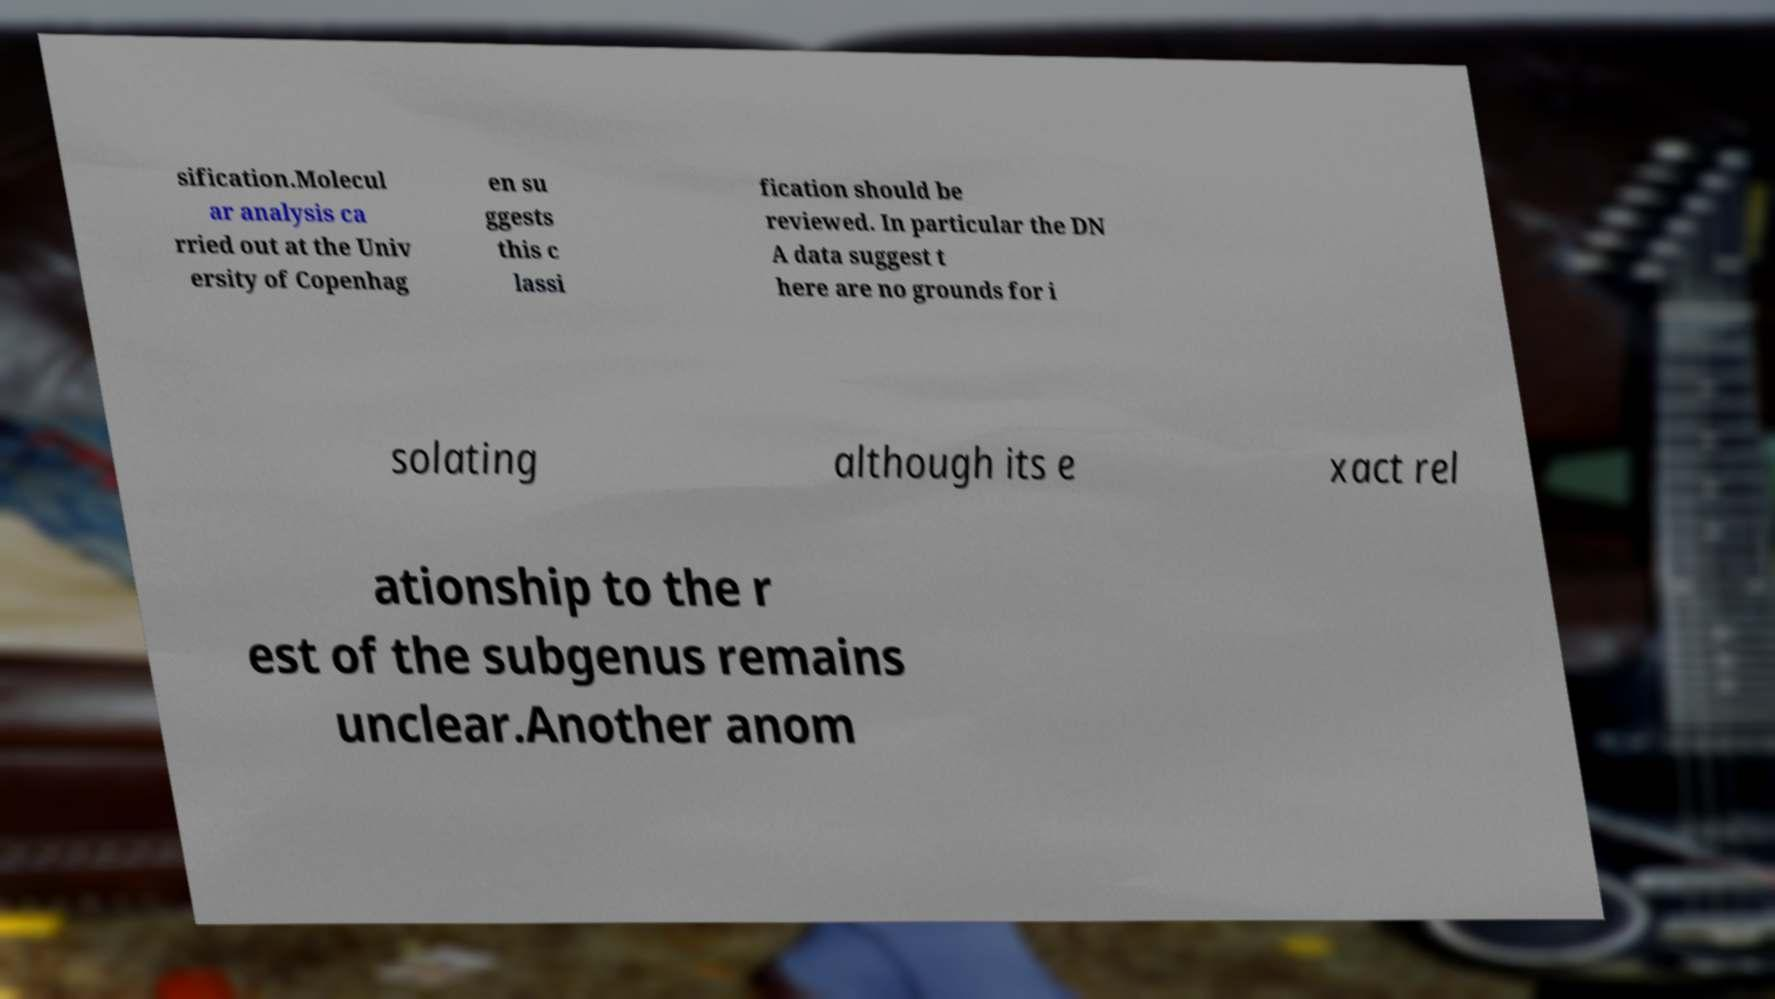Can you read and provide the text displayed in the image?This photo seems to have some interesting text. Can you extract and type it out for me? sification.Molecul ar analysis ca rried out at the Univ ersity of Copenhag en su ggests this c lassi fication should be reviewed. In particular the DN A data suggest t here are no grounds for i solating although its e xact rel ationship to the r est of the subgenus remains unclear.Another anom 